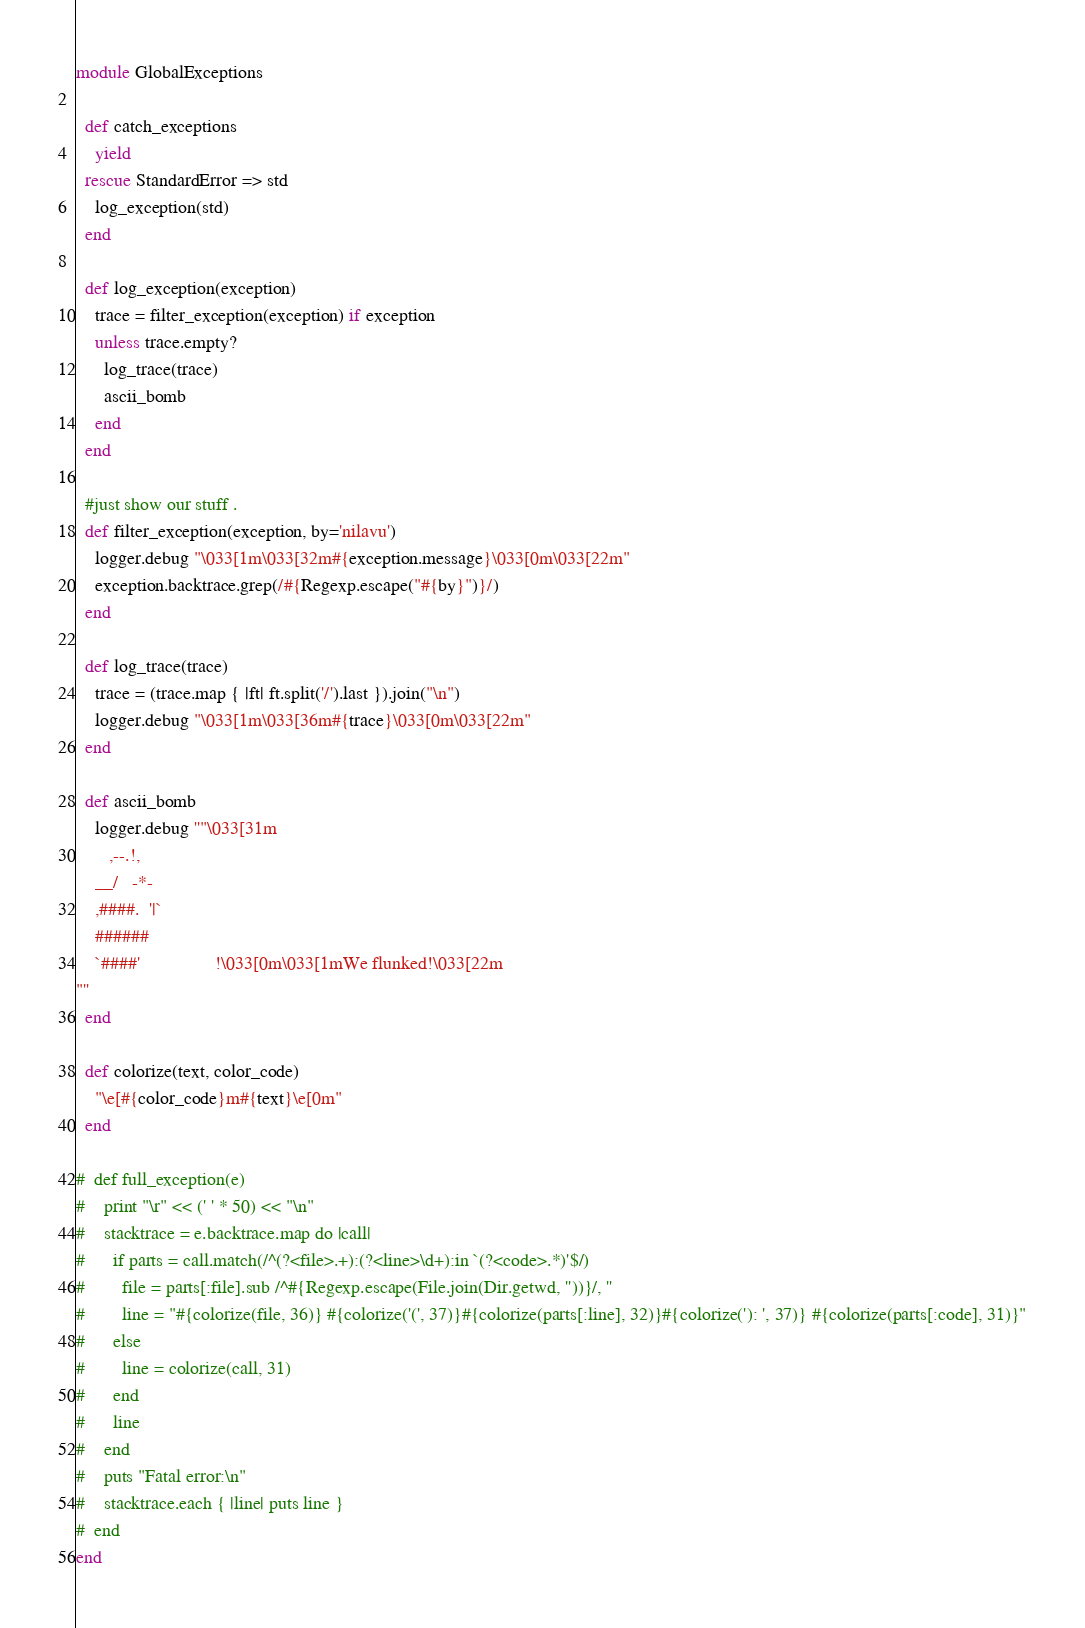<code> <loc_0><loc_0><loc_500><loc_500><_Ruby_>module GlobalExceptions

  def catch_exceptions
    yield
  rescue StandardError => std
    log_exception(std)
  end

  def log_exception(exception)
    trace = filter_exception(exception) if exception
    unless trace.empty?
      log_trace(trace)
      ascii_bomb
    end
  end

  #just show our stuff .
  def filter_exception(exception, by='nilavu')
    logger.debug "\033[1m\033[32m#{exception.message}\033[0m\033[22m"
    exception.backtrace.grep(/#{Regexp.escape("#{by}")}/)
  end

  def log_trace(trace)
    trace = (trace.map { |ft| ft.split('/').last }).join("\n")
    logger.debug "\033[1m\033[36m#{trace}\033[0m\033[22m"
  end

  def ascii_bomb
    logger.debug ''"\033[31m
       ,--.!,
    __/   -*-
	,####.  '|`
	######
	`####'                !\033[0m\033[1mWe flunked!\033[22m
"''
  end

  def colorize(text, color_code)
    "\e[#{color_code}m#{text}\e[0m"
  end

#  def full_exception(e)
#    print "\r" << (' ' * 50) << "\n"
#    stacktrace = e.backtrace.map do |call|
#      if parts = call.match(/^(?<file>.+):(?<line>\d+):in `(?<code>.*)'$/)
#        file = parts[:file].sub /^#{Regexp.escape(File.join(Dir.getwd, ''))}/, ''
#        line = "#{colorize(file, 36)} #{colorize('(', 37)}#{colorize(parts[:line], 32)}#{colorize('): ', 37)} #{colorize(parts[:code], 31)}"
#      else
#        line = colorize(call, 31)
#      end
#      line
#    end
#    puts "Fatal error:\n"
#    stacktrace.each { |line| puts line }
#  end
end
</code> 